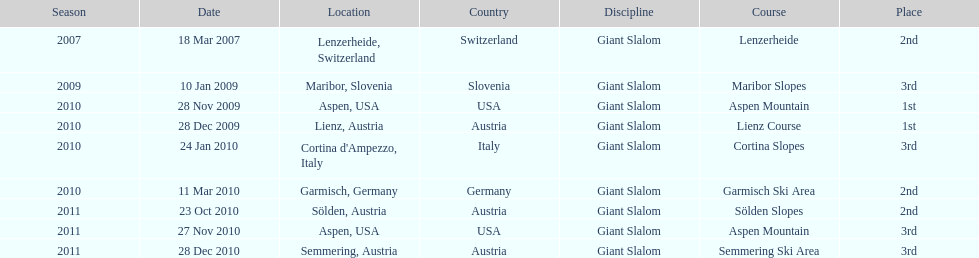Aspen and lienz in 2009 are the only races where this racer got what position? 1st. 